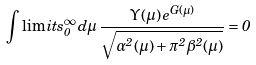<formula> <loc_0><loc_0><loc_500><loc_500>\int \lim i t s _ { 0 } ^ { \infty } \, d \mu \, \frac { \mathit \Upsilon ( \mu ) \, e ^ { G ( \mu ) } } { \sqrt { \alpha ^ { 2 } ( \mu ) + \pi ^ { 2 } \beta ^ { 2 } ( \mu ) } } = 0</formula> 